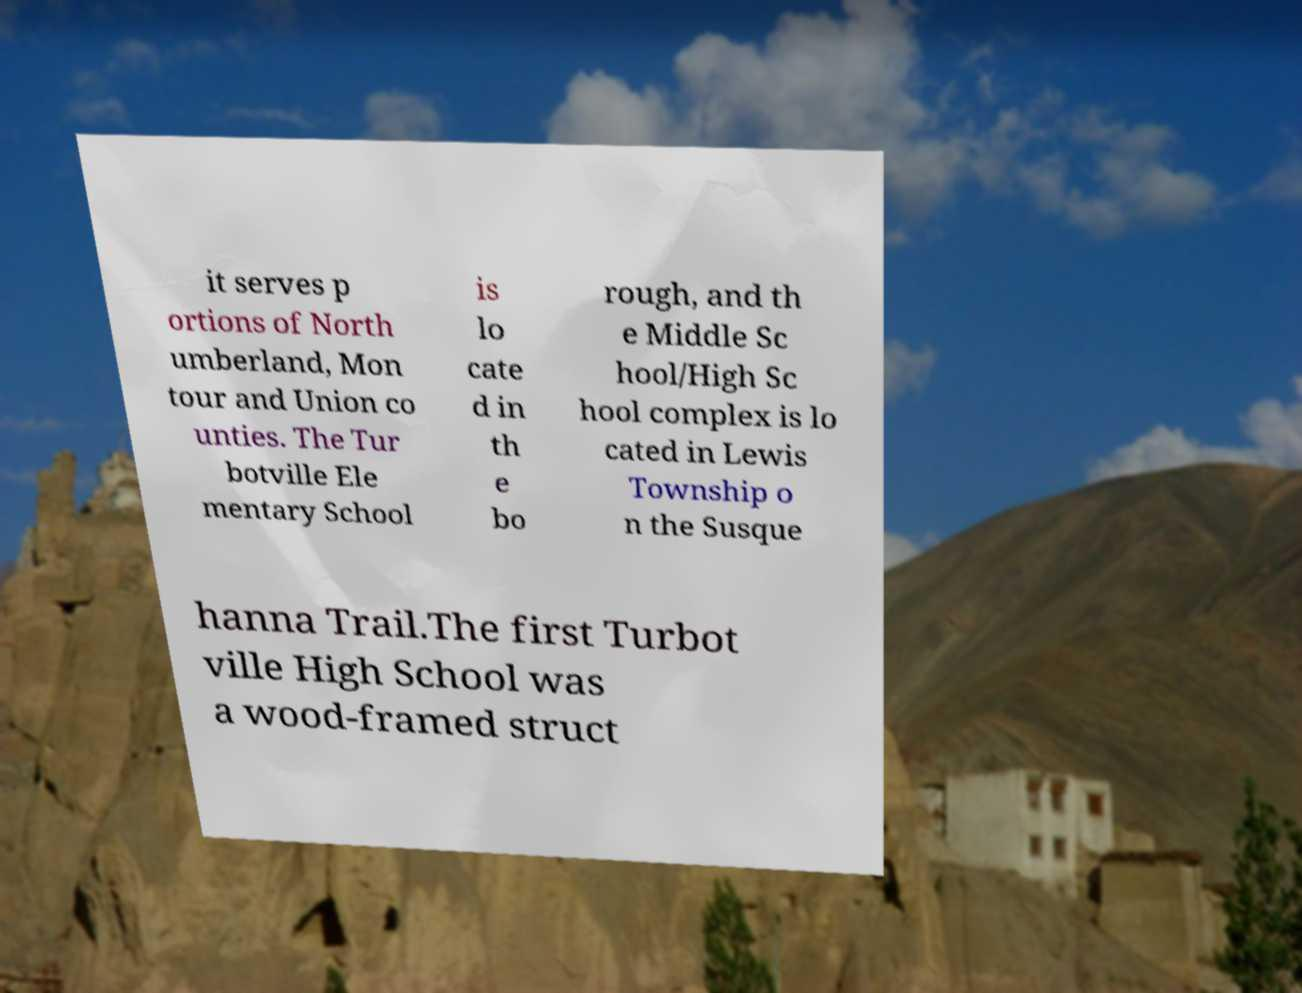Could you assist in decoding the text presented in this image and type it out clearly? it serves p ortions of North umberland, Mon tour and Union co unties. The Tur botville Ele mentary School is lo cate d in th e bo rough, and th e Middle Sc hool/High Sc hool complex is lo cated in Lewis Township o n the Susque hanna Trail.The first Turbot ville High School was a wood-framed struct 